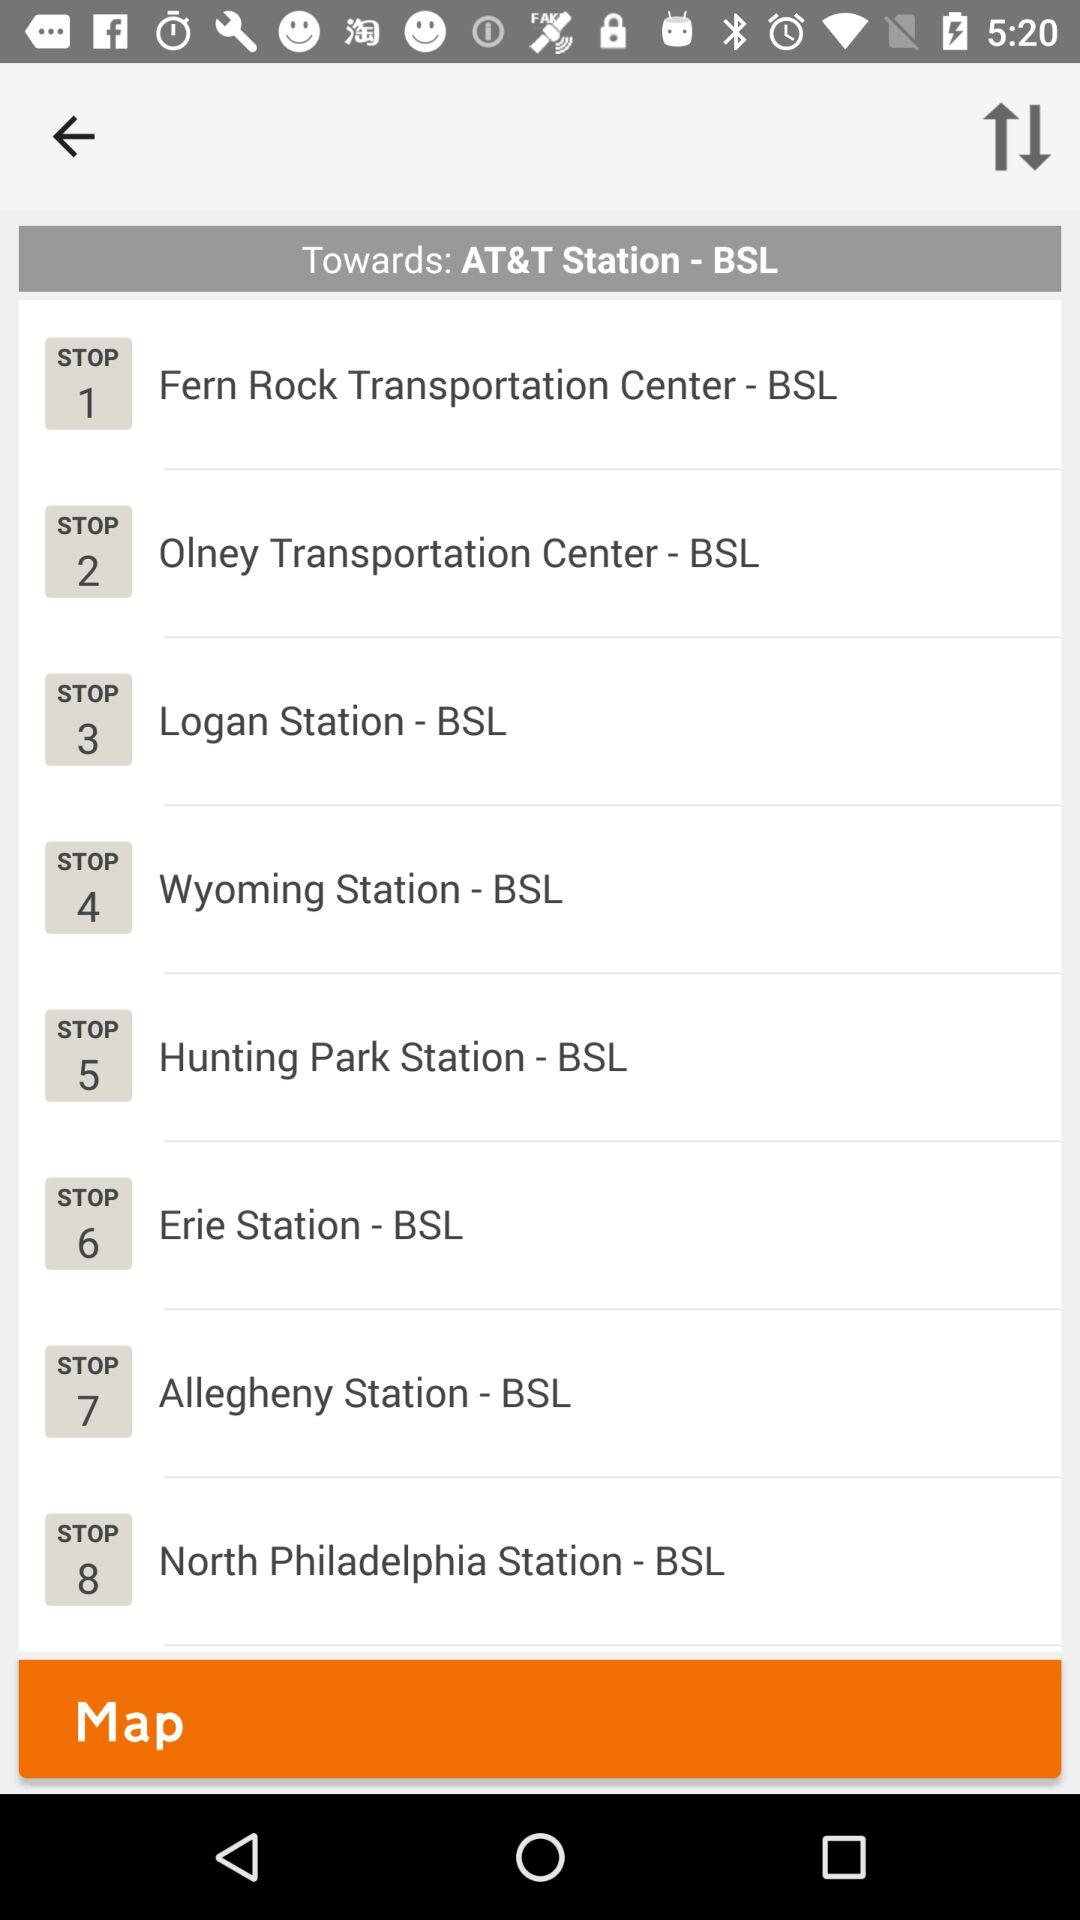How many stops are there on this route?
Answer the question using a single word or phrase. 8 